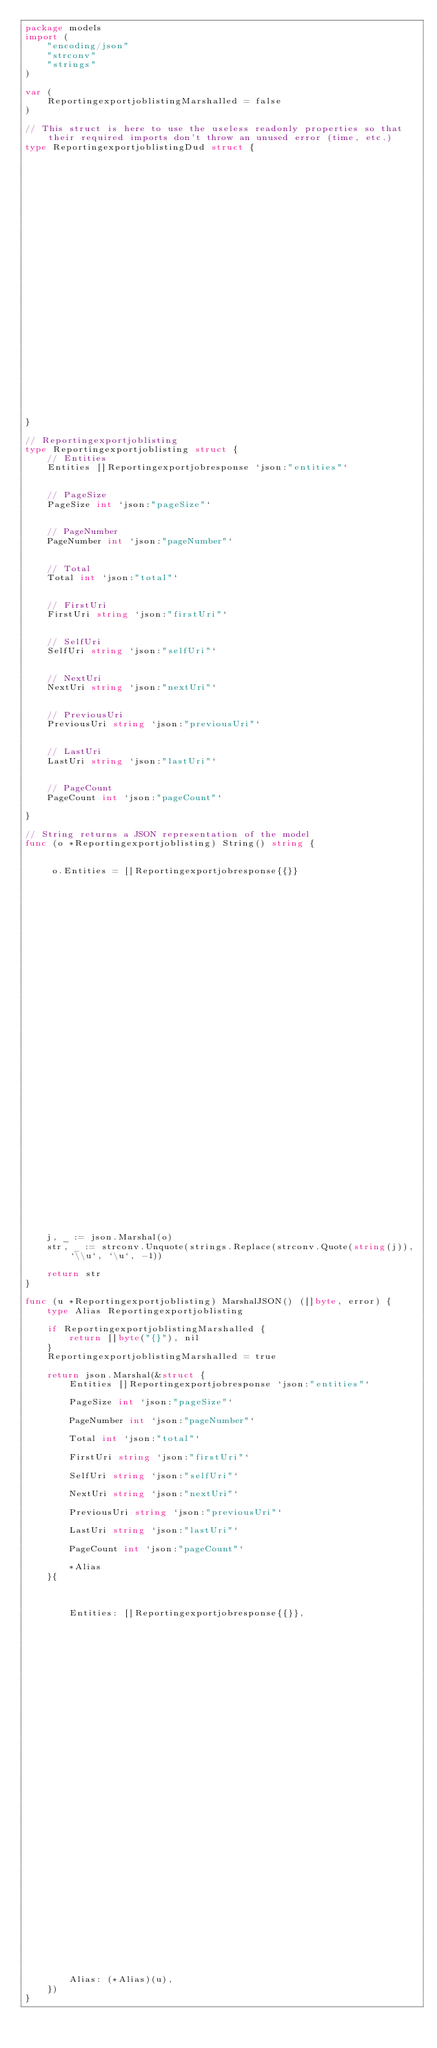Convert code to text. <code><loc_0><loc_0><loc_500><loc_500><_Go_>package models
import (
    "encoding/json"
    "strconv"
    "strings"
)

var (
    ReportingexportjoblistingMarshalled = false
)

// This struct is here to use the useless readonly properties so that their required imports don't throw an unused error (time, etc.)
type ReportingexportjoblistingDud struct { 
    


    


    


    


    


    


    


    


    


    

}

// Reportingexportjoblisting
type Reportingexportjoblisting struct { 
    // Entities
    Entities []Reportingexportjobresponse `json:"entities"`


    // PageSize
    PageSize int `json:"pageSize"`


    // PageNumber
    PageNumber int `json:"pageNumber"`


    // Total
    Total int `json:"total"`


    // FirstUri
    FirstUri string `json:"firstUri"`


    // SelfUri
    SelfUri string `json:"selfUri"`


    // NextUri
    NextUri string `json:"nextUri"`


    // PreviousUri
    PreviousUri string `json:"previousUri"`


    // LastUri
    LastUri string `json:"lastUri"`


    // PageCount
    PageCount int `json:"pageCount"`

}

// String returns a JSON representation of the model
func (o *Reportingexportjoblisting) String() string {
    
    
     o.Entities = []Reportingexportjobresponse{{}} 
    
    
    
    
    
    
    
    
    
    
    
    
    
    
    
    
    
    
    
    
    
    
    
    
    
    
    
    
    
    
    
    
    
    
    
    
    
    

    j, _ := json.Marshal(o)
    str, _ := strconv.Unquote(strings.Replace(strconv.Quote(string(j)), `\\u`, `\u`, -1))

    return str
}

func (u *Reportingexportjoblisting) MarshalJSON() ([]byte, error) {
    type Alias Reportingexportjoblisting

    if ReportingexportjoblistingMarshalled {
        return []byte("{}"), nil
    }
    ReportingexportjoblistingMarshalled = true

    return json.Marshal(&struct { 
        Entities []Reportingexportjobresponse `json:"entities"`
        
        PageSize int `json:"pageSize"`
        
        PageNumber int `json:"pageNumber"`
        
        Total int `json:"total"`
        
        FirstUri string `json:"firstUri"`
        
        SelfUri string `json:"selfUri"`
        
        NextUri string `json:"nextUri"`
        
        PreviousUri string `json:"previousUri"`
        
        LastUri string `json:"lastUri"`
        
        PageCount int `json:"pageCount"`
        
        *Alias
    }{
        

        
        Entities: []Reportingexportjobresponse{{}},
        

        

        

        

        

        

        

        

        

        

        

        

        

        

        

        

        

        

        

        
        Alias: (*Alias)(u),
    })
}

</code> 